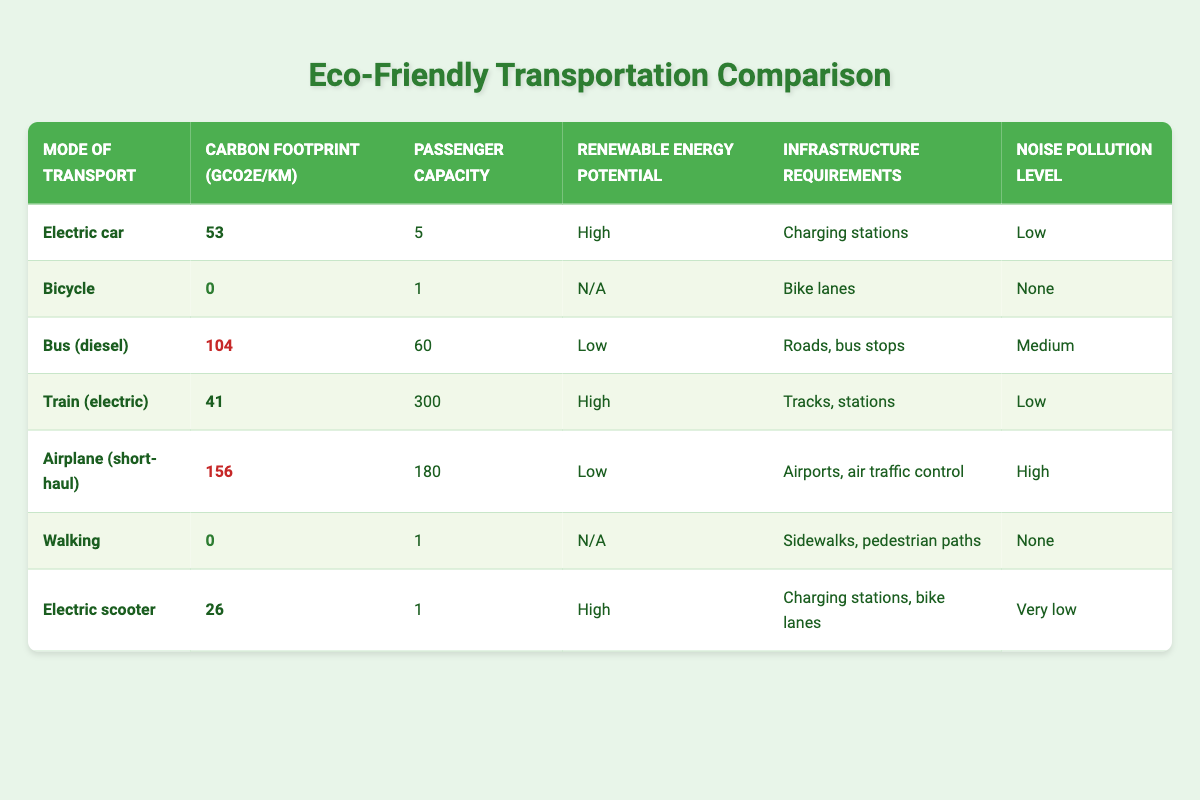What is the carbon footprint of a bicycle per kilometer? The table shows the carbon footprint for a bicycle as 0 gCO2e/km.
Answer: 0 gCO2e/km What mode of transport has the highest passenger capacity? According to the table, the train (electric) has a passenger capacity of 300, which is the highest among all listed modes.
Answer: Train (electric) Does walking produce any carbon emissions? The table indicates a carbon footprint of 0 gCO2e/km for walking, meaning it does not produce any carbon emissions.
Answer: Yes What is the difference in carbon footprint between an airplane (short-haul) and a train (electric)? From the table, the carbon footprint for an airplane (short-haul) is 156 gCO2e/km and for a train (electric) is 41 gCO2e/km. The difference is calculated as 156 - 41 = 115 gCO2e/km.
Answer: 115 gCO2e/km What mode of transportation produces the least noise pollution? In the table, both the bicycle and walking have a noise pollution level of "None," indicating they produce the least noise.
Answer: Bicycle and Walking If a family of 5 takes an electric car for a journey of 10 km, how much carbon will they emit? The carbon footprint for an electric car is 53 gCO2e/km. For a 10 km journey, the total carbon emissions would be calculated as 53 * 10 = 530 gCO2e.
Answer: 530 gCO2e Which modes of transport have a high potential for renewable energy? The table lists the electric car, train (electric), and electric scooter as having high renewable energy potential.
Answer: Electric car, Train (electric), Electric scooter Is there a mode of transport that has a carbon footprint equal to zero? Yes, both the bicycle and walking have a carbon footprint of 0 gCO2e/km, indicating they do not produce carbon emissions.
Answer: Yes Which mode of transport requires charging stations? The table shows that both the electric car and the electric scooter require charging stations.
Answer: Electric car and Electric scooter 